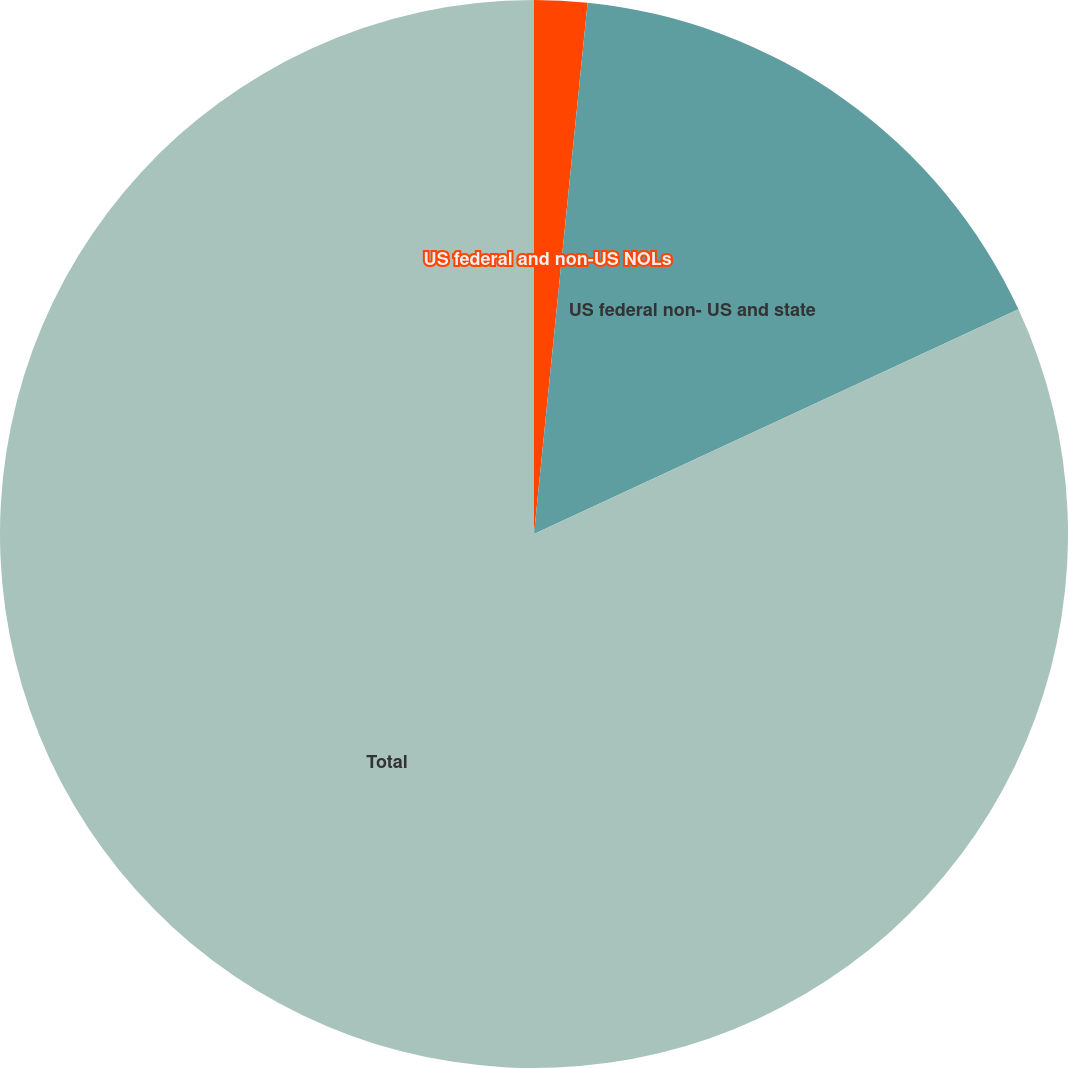Convert chart to OTSL. <chart><loc_0><loc_0><loc_500><loc_500><pie_chart><fcel>US federal and non-US NOLs<fcel>US federal non- US and state<fcel>Total<nl><fcel>1.6%<fcel>16.49%<fcel>81.91%<nl></chart> 